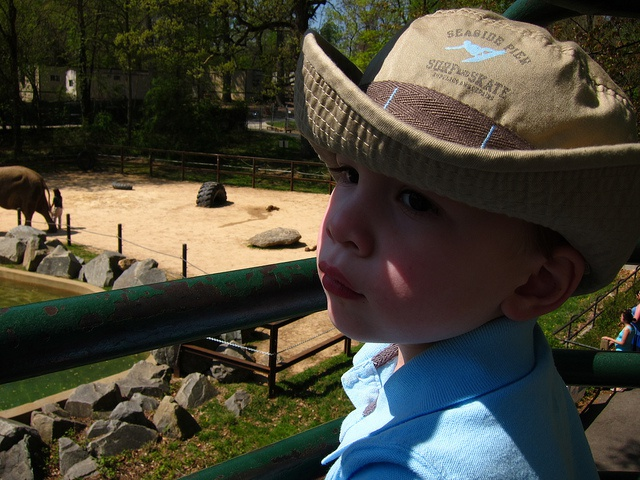Describe the objects in this image and their specific colors. I can see people in black, gray, maroon, and tan tones, elephant in black, maroon, and gray tones, people in black, brown, maroon, and salmon tones, people in black, maroon, olive, and gray tones, and people in black, lightpink, maroon, and brown tones in this image. 